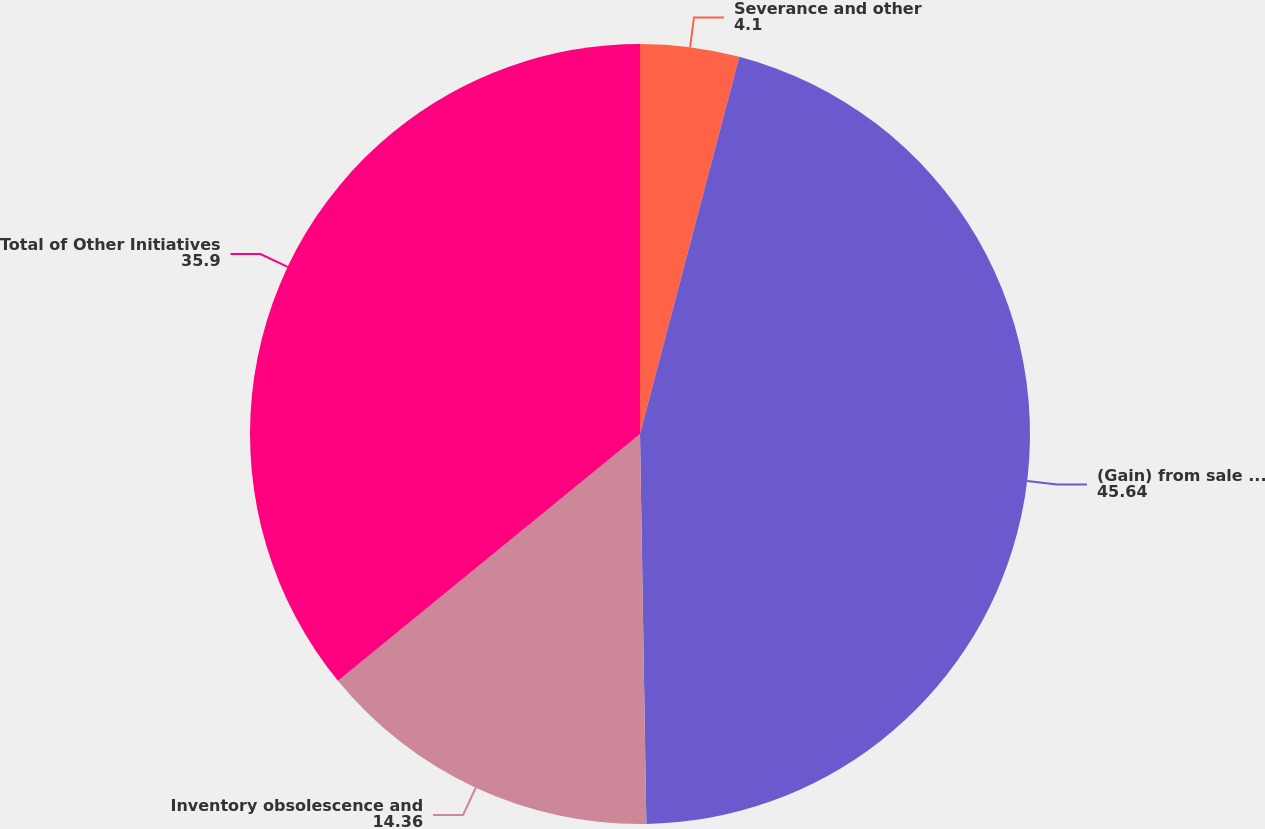Convert chart. <chart><loc_0><loc_0><loc_500><loc_500><pie_chart><fcel>Severance and other<fcel>(Gain) from sale of assets (2)<fcel>Inventory obsolescence and<fcel>Total of Other Initiatives<nl><fcel>4.1%<fcel>45.64%<fcel>14.36%<fcel>35.9%<nl></chart> 